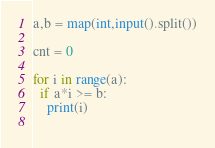Convert code to text. <code><loc_0><loc_0><loc_500><loc_500><_Python_>a,b = map(int,input().split())

cnt = 0

for i in range(a):
  if a*i >= b:
    print(i)
  </code> 